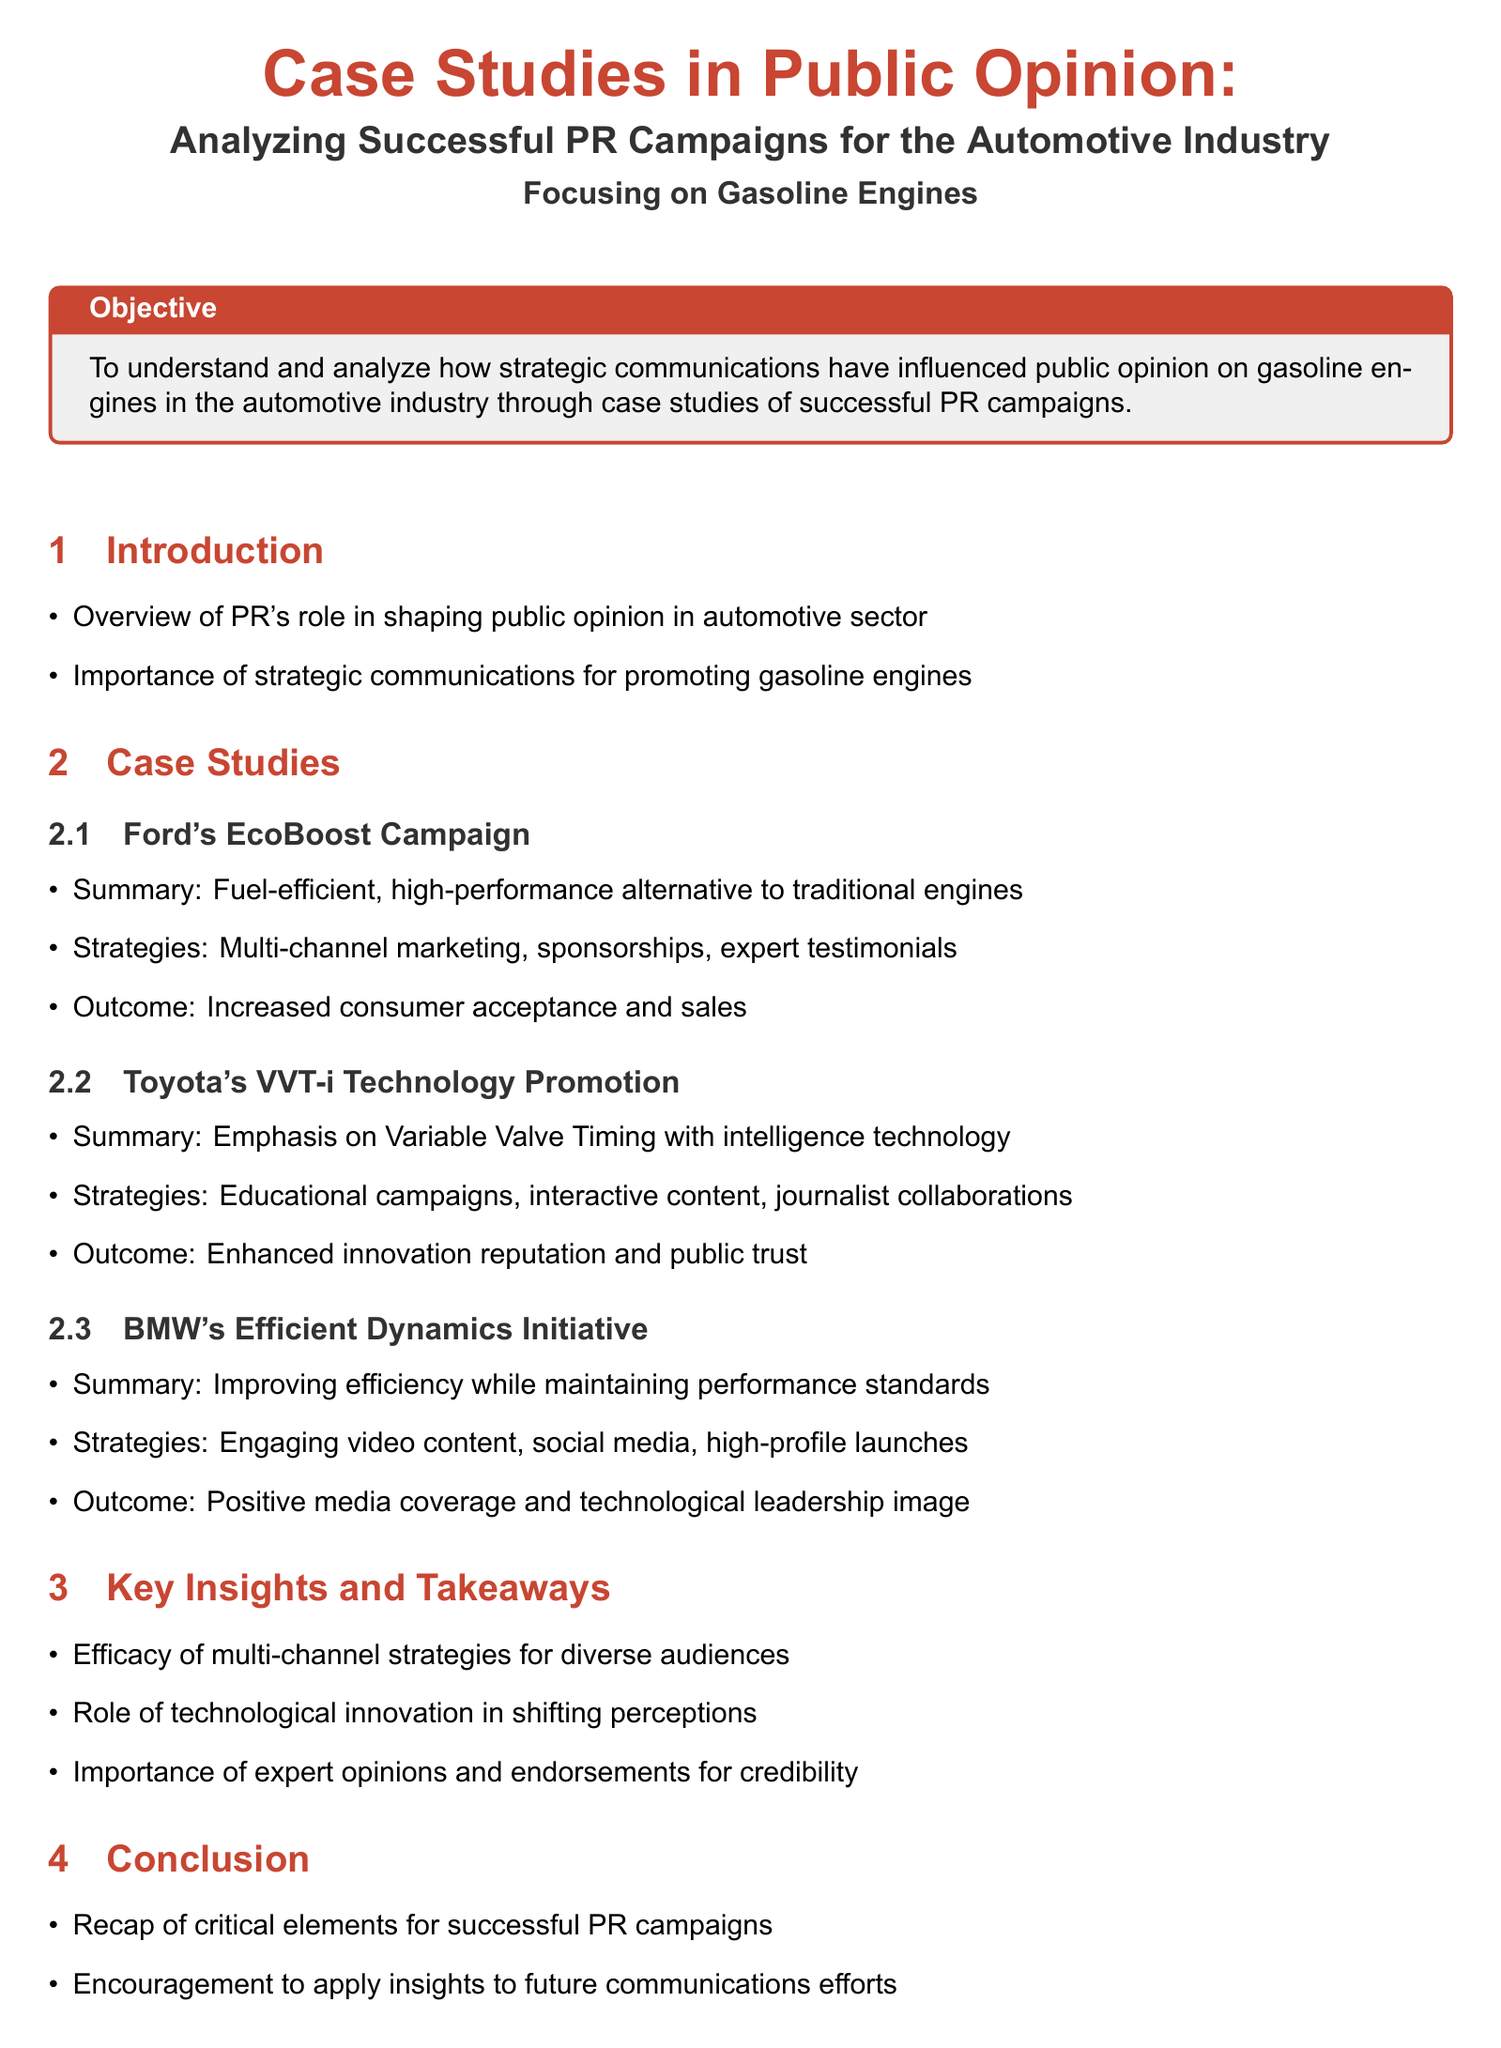What is the objective of the lesson plan? The objective is to understand and analyze how strategic communications have influenced public opinion on gasoline engines in the automotive industry through case studies of successful PR campaigns.
Answer: To understand and analyze how strategic communications have influenced public opinion on gasoline engines in the automotive industry through case studies of successful PR campaigns What campaign is associated with Ford? Ford's EcoBoost campaign focuses on a fuel-efficient, high-performance alternative to traditional engines.
Answer: Ford's EcoBoost Campaign Which company's technology is highlighted in the case study for Variable Valve Timing? The document highlights Toyota's technology for Variable Valve Timing with intelligence.
Answer: Toyota What strategy did BMW use in their Efficient Dynamics Initiative? Engaging video content was one of the strategies used in BMW's Efficient Dynamics Initiative.
Answer: Engaging video content What was a key insight about the role of technological innovation? The document states that technological innovation plays a role in shifting perceptions.
Answer: Shifting perceptions How many case studies are presented in the document? There are three case studies presented: Ford, Toyota, and BMW.
Answer: Three What type of reading does the further reading section encourage? The further reading section encourages analysis and case studies related to automobile PR campaigns.
Answer: Analysis and case studies What was the outcome of Toyota's VVT-i campaign? The outcome was enhanced innovation reputation and public trust.
Answer: Enhanced innovation reputation and public trust 